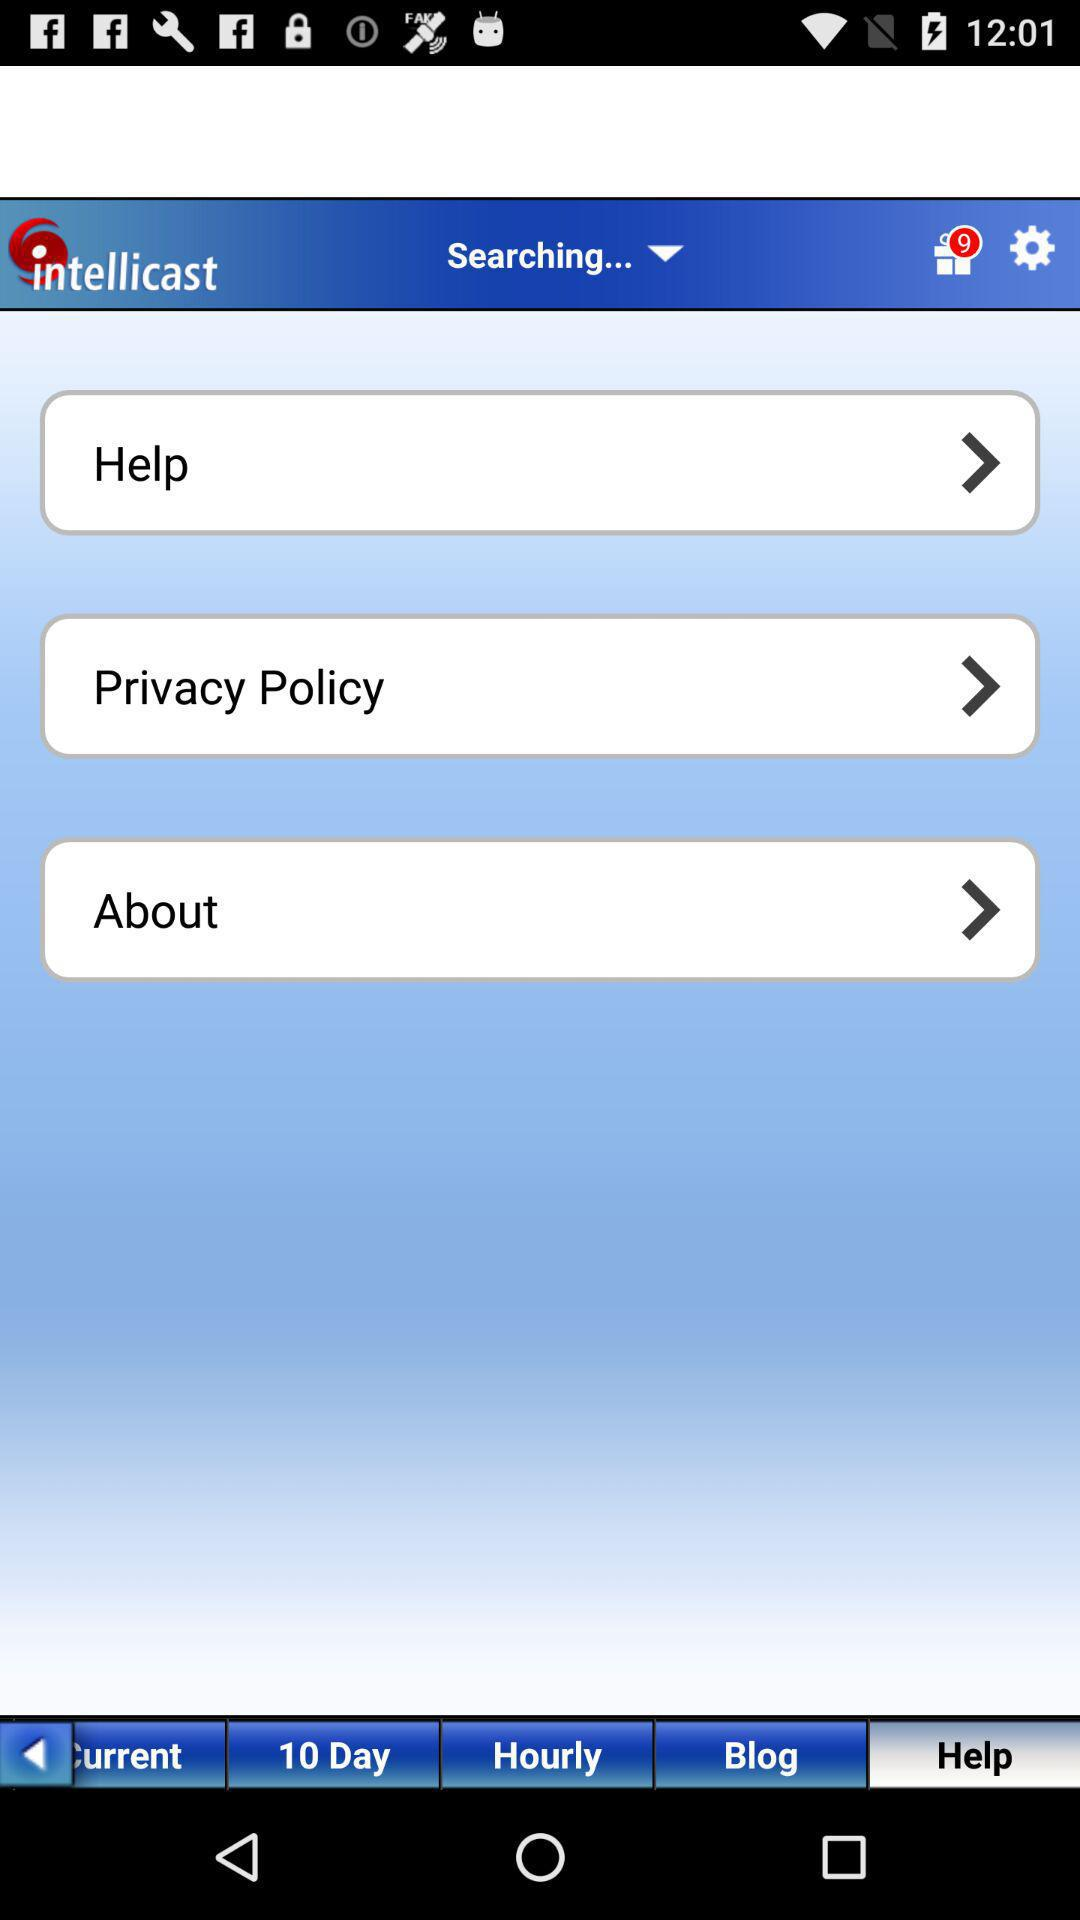How many notifications are there? There are 9 notifications. 